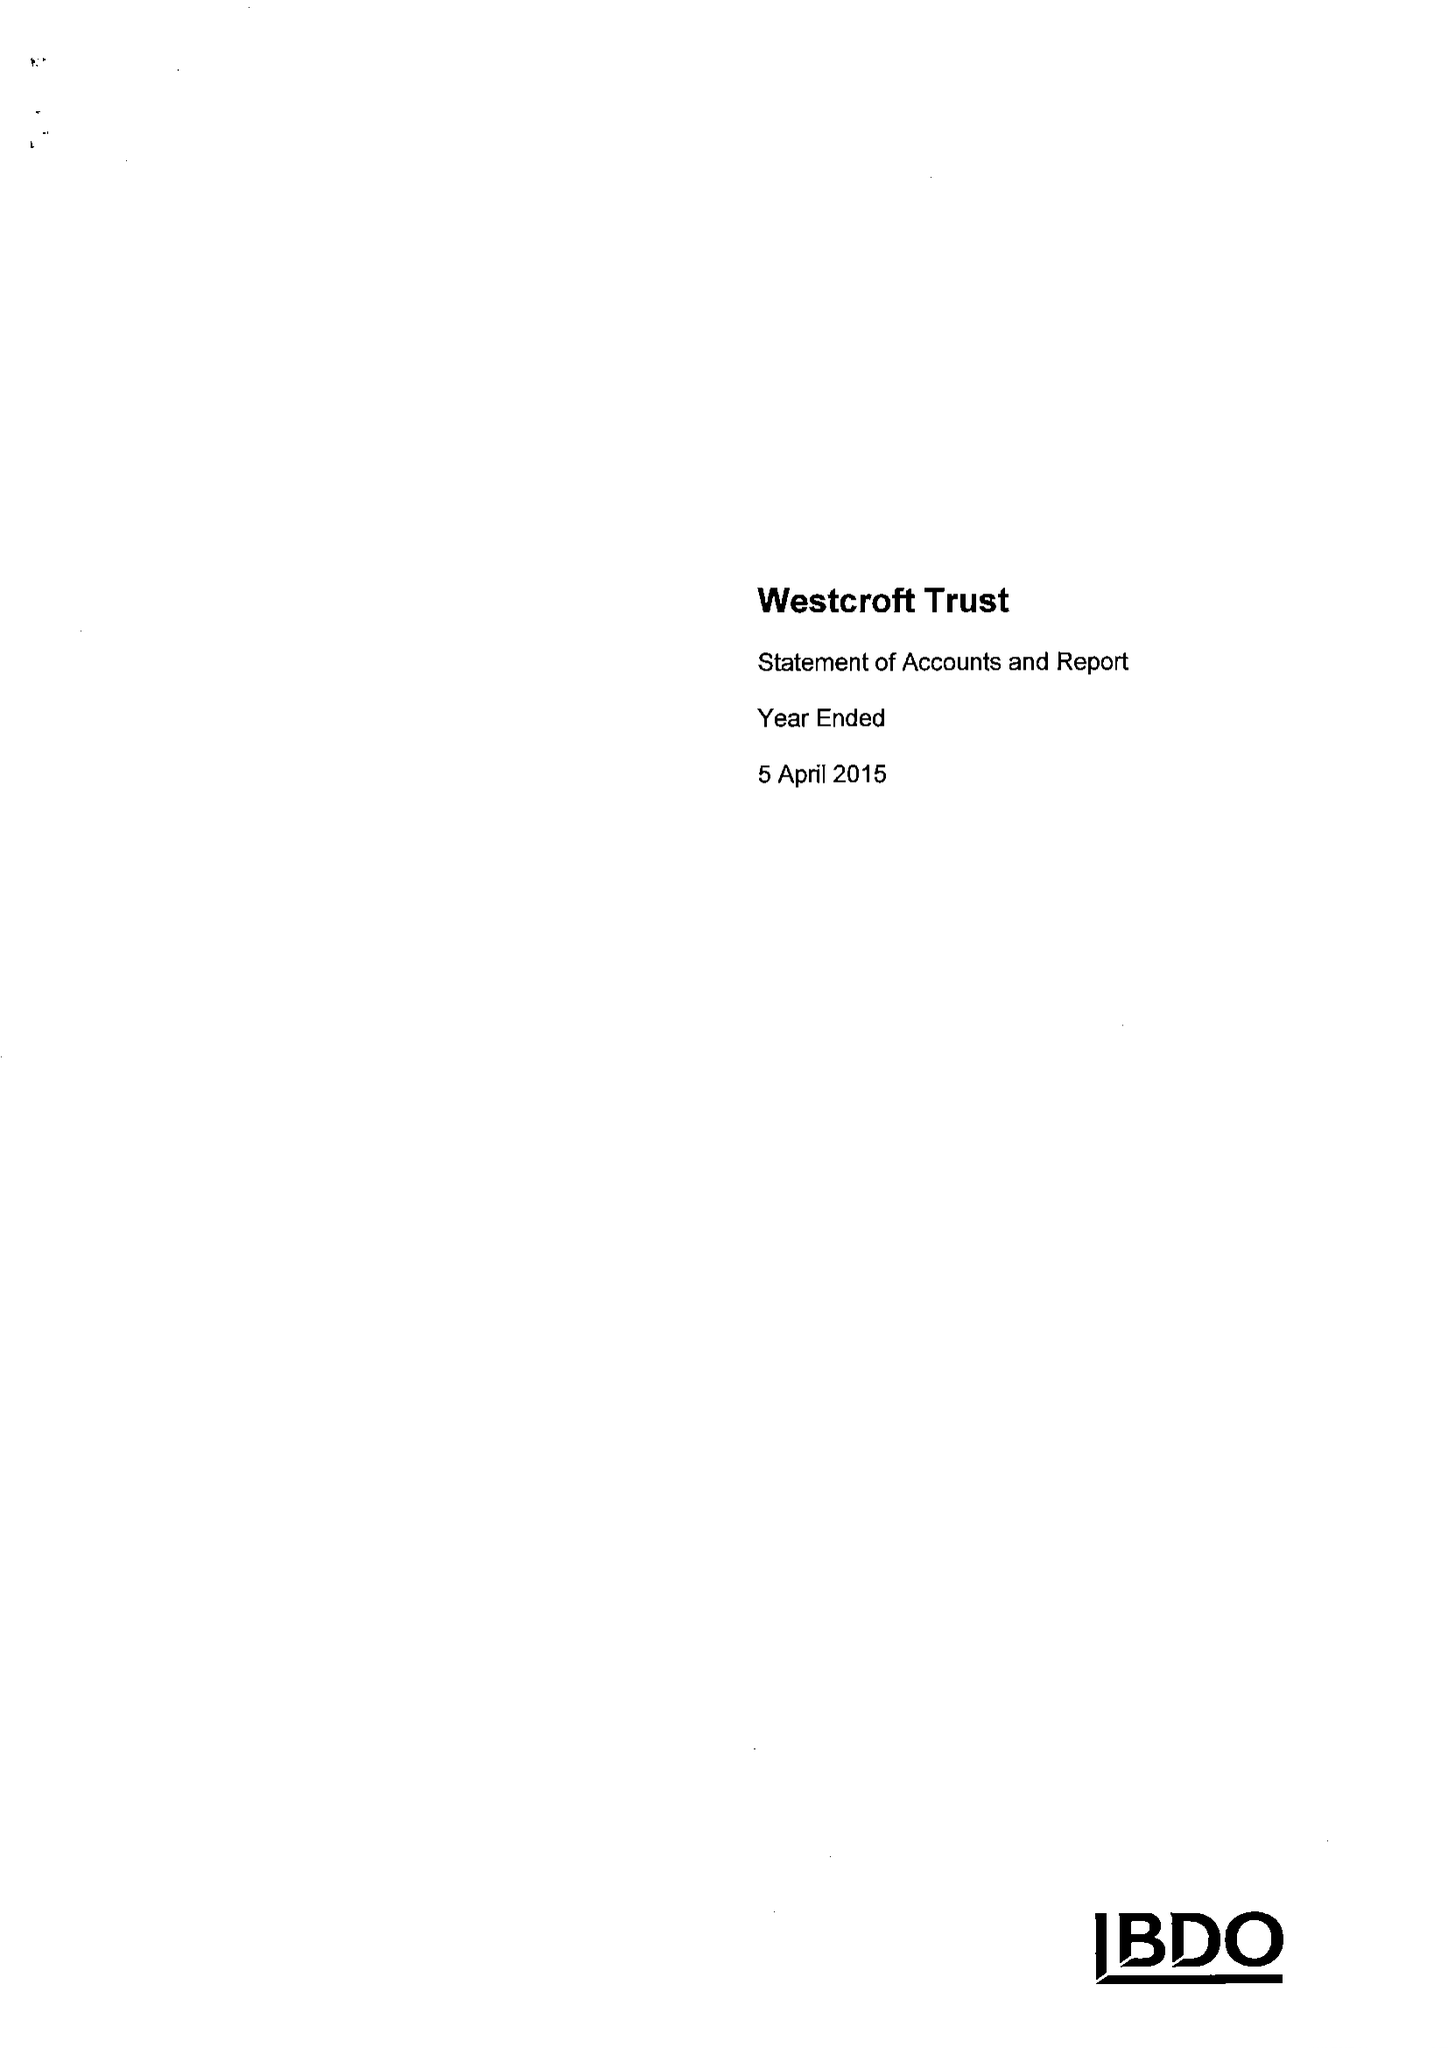What is the value for the report_date?
Answer the question using a single word or phrase. 2015-04-05 